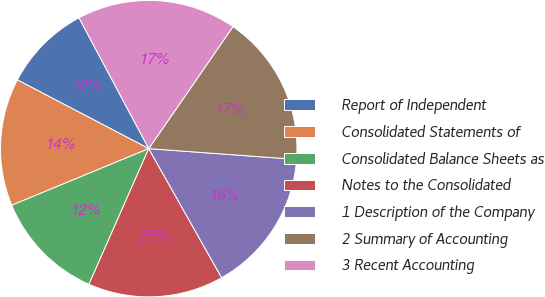Convert chart. <chart><loc_0><loc_0><loc_500><loc_500><pie_chart><fcel>Report of Independent<fcel>Consolidated Statements of<fcel>Consolidated Balance Sheets as<fcel>Notes to the Consolidated<fcel>1 Description of the Company<fcel>2 Summary of Accounting<fcel>3 Recent Accounting<nl><fcel>9.53%<fcel>13.91%<fcel>12.16%<fcel>14.79%<fcel>15.66%<fcel>16.54%<fcel>17.42%<nl></chart> 